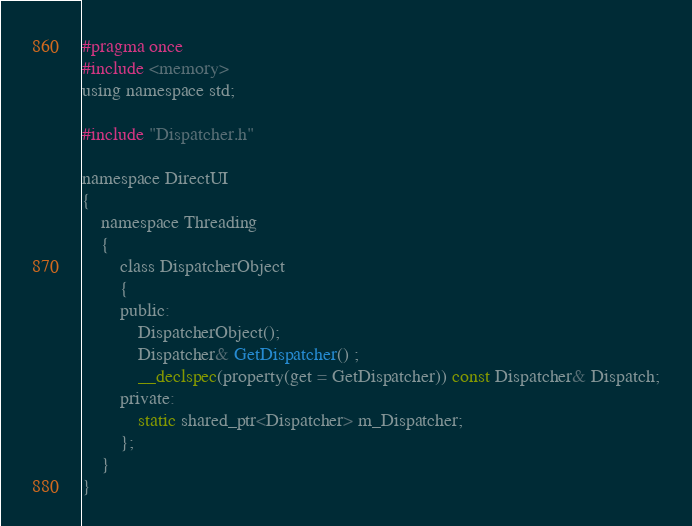Convert code to text. <code><loc_0><loc_0><loc_500><loc_500><_C_>#pragma once
#include <memory>
using namespace std;

#include "Dispatcher.h"

namespace DirectUI
{
	namespace Threading
	{
		class DispatcherObject
		{
		public:
			DispatcherObject();
			Dispatcher& GetDispatcher() ;
			__declspec(property(get = GetDispatcher)) const Dispatcher& Dispatch;
		private:
			static shared_ptr<Dispatcher> m_Dispatcher;
		};
	}
}


</code> 